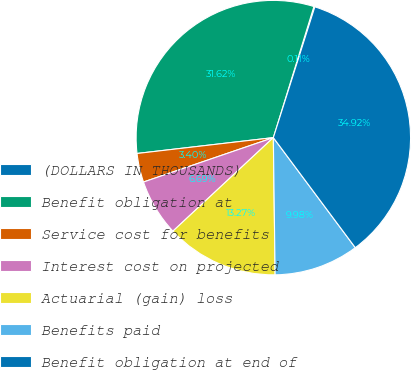<chart> <loc_0><loc_0><loc_500><loc_500><pie_chart><fcel>(DOLLARS IN THOUSANDS)<fcel>Benefit obligation at<fcel>Service cost for benefits<fcel>Interest cost on projected<fcel>Actuarial (gain) loss<fcel>Benefits paid<fcel>Benefit obligation at end of<nl><fcel>0.11%<fcel>31.62%<fcel>3.4%<fcel>6.69%<fcel>13.27%<fcel>9.98%<fcel>34.92%<nl></chart> 